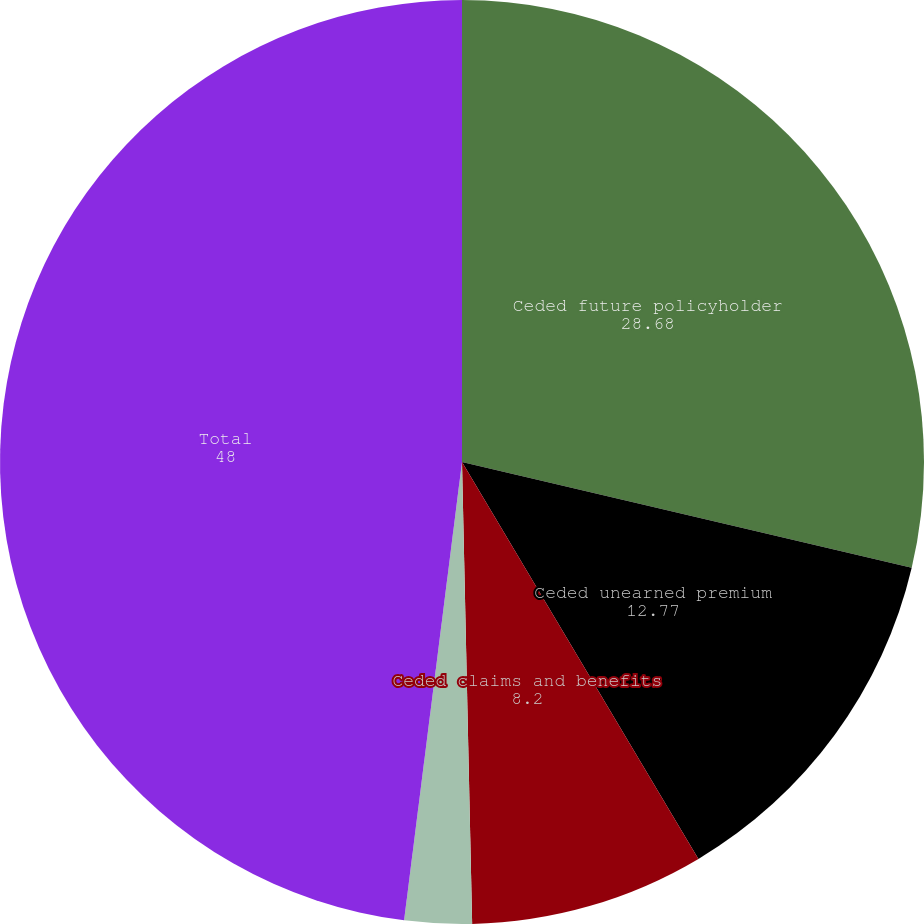Convert chart to OTSL. <chart><loc_0><loc_0><loc_500><loc_500><pie_chart><fcel>Ceded future policyholder<fcel>Ceded unearned premium<fcel>Ceded claims and benefits<fcel>Ceded paid losses<fcel>Total<nl><fcel>28.68%<fcel>12.77%<fcel>8.2%<fcel>2.35%<fcel>48.0%<nl></chart> 